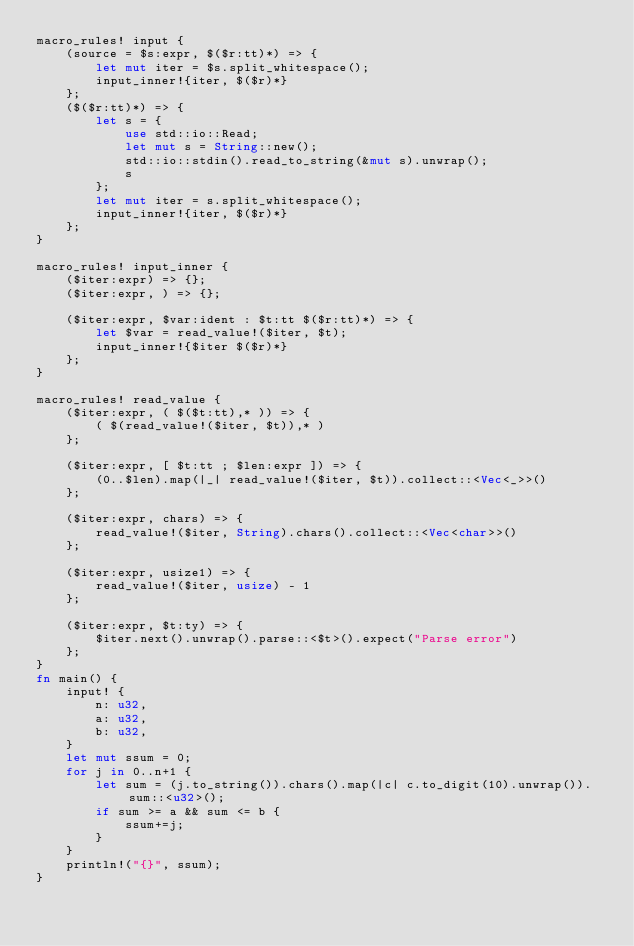<code> <loc_0><loc_0><loc_500><loc_500><_Rust_>macro_rules! input {
    (source = $s:expr, $($r:tt)*) => {
        let mut iter = $s.split_whitespace();
        input_inner!{iter, $($r)*}
    };
    ($($r:tt)*) => {
        let s = {
            use std::io::Read;
            let mut s = String::new();
            std::io::stdin().read_to_string(&mut s).unwrap();
            s
        };
        let mut iter = s.split_whitespace();
        input_inner!{iter, $($r)*}
    };
}

macro_rules! input_inner {
    ($iter:expr) => {};
    ($iter:expr, ) => {};

    ($iter:expr, $var:ident : $t:tt $($r:tt)*) => {
        let $var = read_value!($iter, $t);
        input_inner!{$iter $($r)*}
    };
}

macro_rules! read_value {
    ($iter:expr, ( $($t:tt),* )) => {
        ( $(read_value!($iter, $t)),* )
    };

    ($iter:expr, [ $t:tt ; $len:expr ]) => {
        (0..$len).map(|_| read_value!($iter, $t)).collect::<Vec<_>>()
    };

    ($iter:expr, chars) => {
        read_value!($iter, String).chars().collect::<Vec<char>>()
    };

    ($iter:expr, usize1) => {
        read_value!($iter, usize) - 1
    };

    ($iter:expr, $t:ty) => {
        $iter.next().unwrap().parse::<$t>().expect("Parse error")
    };
}
fn main() {
    input! {
        n: u32,
        a: u32,
        b: u32,
    }
    let mut ssum = 0;
    for j in 0..n+1 {
        let sum = (j.to_string()).chars().map(|c| c.to_digit(10).unwrap()).sum::<u32>();
        if sum >= a && sum <= b {
            ssum+=j;
        }
    }
    println!("{}", ssum);
}</code> 